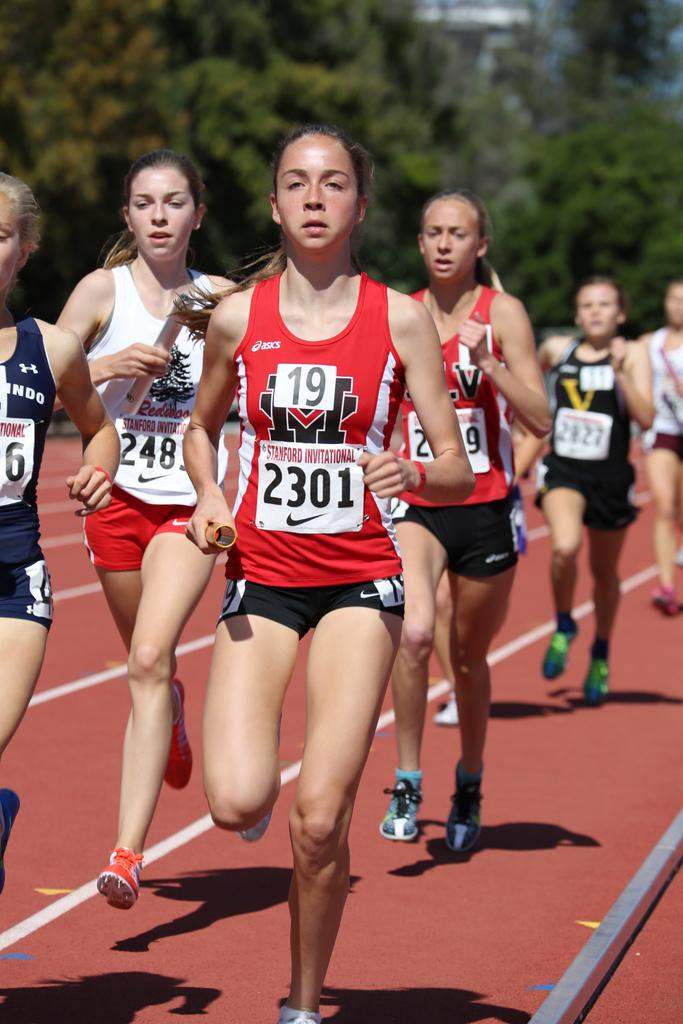<image>
Render a clear and concise summary of the photo. A girl wearing a red tank top and the number 2301 runs in front of other girls on a track. 